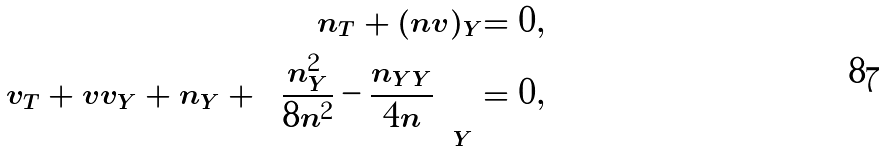<formula> <loc_0><loc_0><loc_500><loc_500>n _ { T } + ( n v ) _ { Y } = 0 , \\ v _ { T } + v v _ { Y } + n _ { Y } + \left ( \frac { n _ { Y } ^ { 2 } } { 8 n ^ { 2 } } - \frac { n _ { Y Y } } { 4 n } \right ) _ { Y } = 0 ,</formula> 